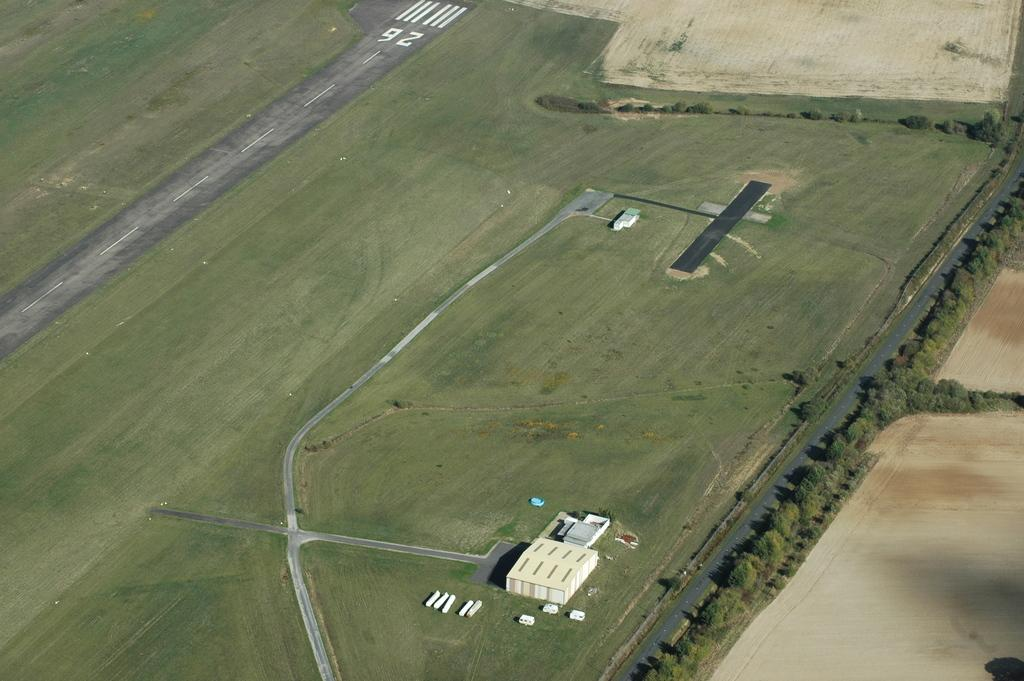What type of surface can be seen in the image? There is ground visible in the image. What type of infrastructure is present in the image? There are roads in the image. What type of vegetation is present in the image? There are trees in the image. What type of man-made structures are present in the image? There are buildings in the image. What other objects can be seen in the image? There are other objects in the image. How does the grandmother express regret in the image? There is no grandmother or expression of regret present in the image. 